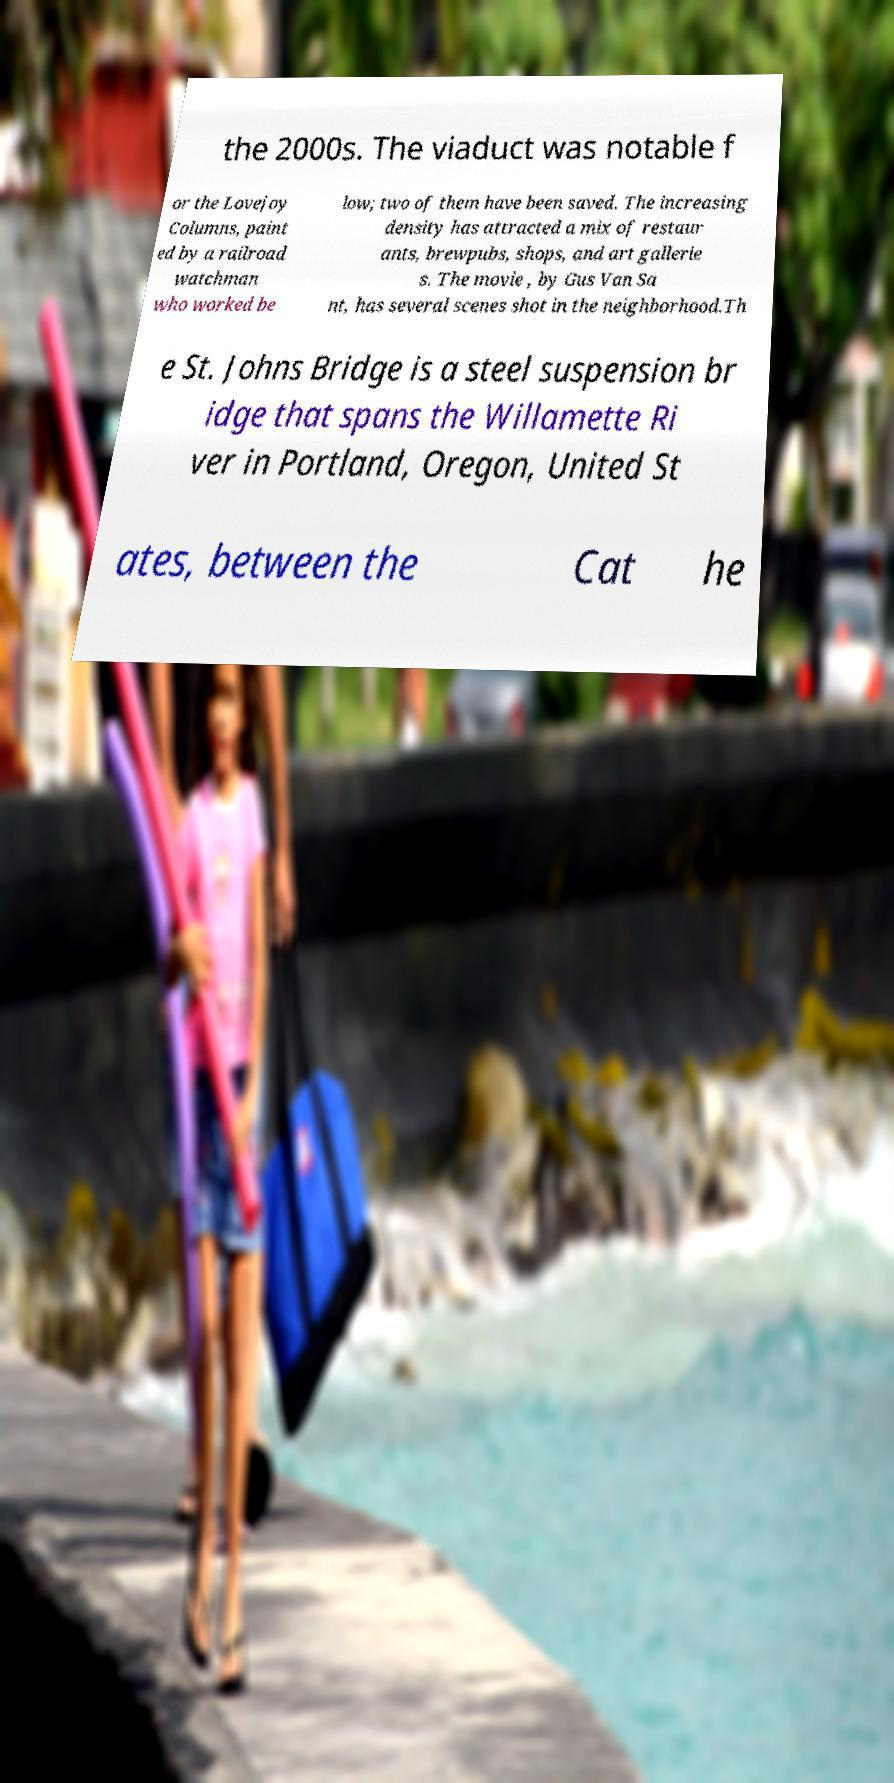Can you accurately transcribe the text from the provided image for me? the 2000s. The viaduct was notable f or the Lovejoy Columns, paint ed by a railroad watchman who worked be low; two of them have been saved. The increasing density has attracted a mix of restaur ants, brewpubs, shops, and art gallerie s. The movie , by Gus Van Sa nt, has several scenes shot in the neighborhood.Th e St. Johns Bridge is a steel suspension br idge that spans the Willamette Ri ver in Portland, Oregon, United St ates, between the Cat he 